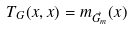Convert formula to latex. <formula><loc_0><loc_0><loc_500><loc_500>T _ { G } ( x , x ) = m _ { \vec { G } _ { m } } ( x )</formula> 